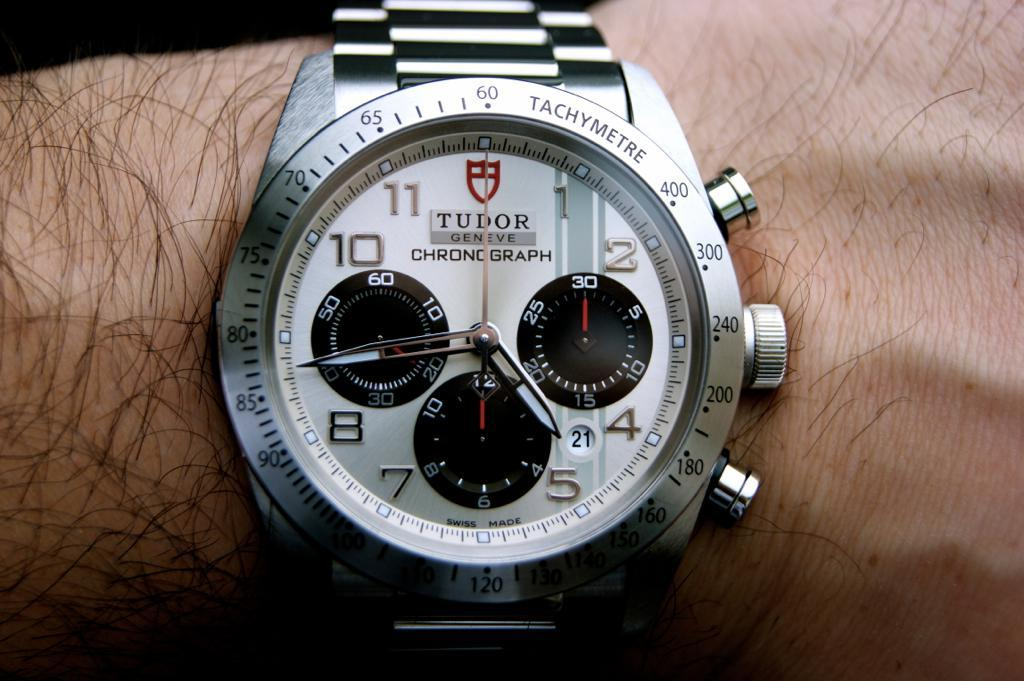<image>
Write a terse but informative summary of the picture. A TUDOR watch points to the numbers 5 and 9 